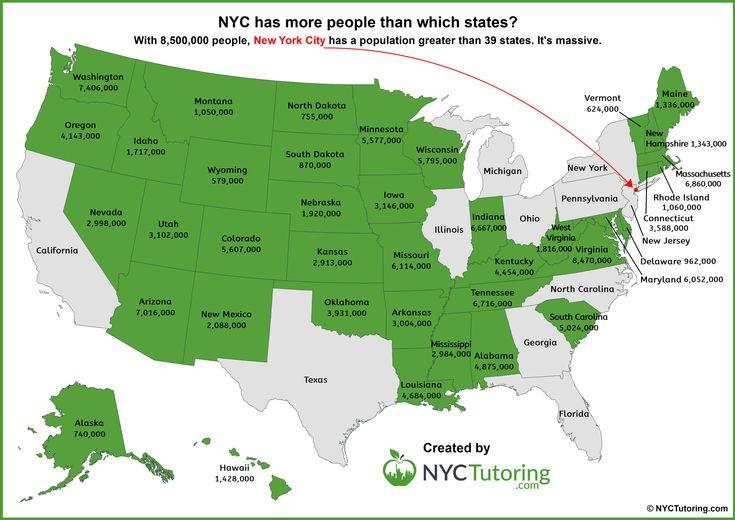Highlight a few significant elements in this photo. The population of Iowa is 3,146,000. The population of Alaska is approximately 740,000. The city with the largest population in the United States is New York City, located in the state of New York. 